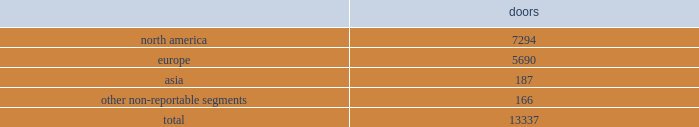No operating segments were aggregated to form our reportable segments .
In addition to these reportable segments , we also have other non-reportable segments , representing approximately 7% ( 7 % ) of our fiscal 2017 net revenues , which primarily consist of ( i ) sales of our club monaco branded products made through our retail businesses in the u.s. , canada , and europe , ( ii ) sales of our ralph lauren branded products made through our wholesale business in latin america , and ( iii ) royalty revenues earned through our global licensing alliances .
This new segment structure is consistent with how we establish our overall business strategy , allocate resources , and assess performance of our company .
All prior period segment information has been recast to reflect the realignment of our segment reporting structure on a comparable basis .
Approximately 40% ( 40 % ) of our fiscal 2017 net revenues were earned outside of the u.s .
See note 20 to the accompanying consolidated financial statements for a summary of net revenues and operating income by segment , as well as net revenues and long-lived assets by geographic location .
Our wholesale business our wholesale business sells our products globally to leading upscale and certain mid-tier department stores , specialty stores , and golf and pro shops .
We have continued to focus on elevating our brand by improving in-store product assortment and presentation , as well as full-price sell-throughs to consumers .
As of the end of fiscal 2017 , our wholesale products were sold through over 13000 doors worldwide , with the majority in specialty stores .
Our products are also sold through the e-commerce sites of certain of our wholesale customers .
The primary product offerings sold through our wholesale channels of distribution include apparel , accessories , and home furnishings .
Our luxury brands 2014 ralph lauren collection and ralph lauren purple label 2014 are distributed worldwide through a limited number of premier fashion retailers .
Department stores are our major wholesale customers in north america .
In latin america , our wholesale products are sold in department stores and specialty stores .
In europe , our wholesale sales are comprised of a varying mix of sales to both department stores and specialty stores , depending on the country .
In asia , our wholesale products are distributed primarily through shop-within-shops at department stores .
We also distribute our wholesale products to certain licensed stores operated by our partners in latin america , asia , europe , and the middle east .
We sell the majority of our excess and out-of-season products through secondary distribution channels worldwide , including our retail factory stores .
Worldwide wholesale distribution channels the table presents the number of wholesale doors by segment as of april 1 , 2017: .
We have three key wholesale customers that generate significant sales volume .
During fiscal 2017 , sales to our largest wholesale customer , macy's , inc .
( "macy's" ) , accounted for approximately 10% ( 10 % ) of our total net revenues .
Further , during fiscal 2017 , sales to our three largest wholesale customers , including macy's , accounted for approximately 21% ( 21 % ) of our total net revenues .
Substantially all sales to our three largest wholesale customers related to our north america segment .
Our products are sold primarily by our own sales forces .
Our wholesale business maintains its primary showrooms in new york city .
In addition , we maintain regional showrooms in milan , paris , london , munich , madrid , stockholm , and panama. .
What percentage of wholesale doors as of april 1 , 2017 where in the europe segment? 
Computations: (5690 / 13337)
Answer: 0.42663. 